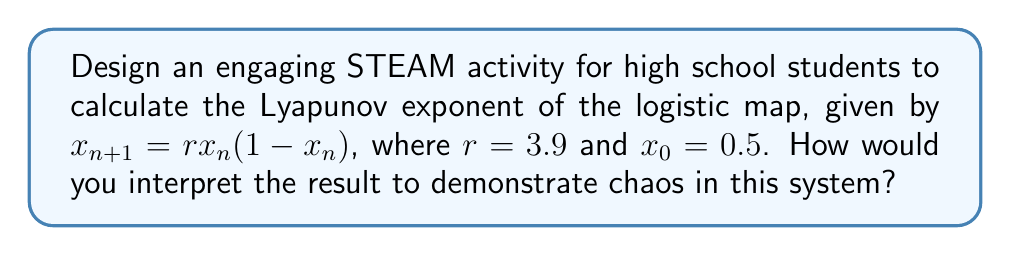Solve this math problem. To calculate the Lyapunov exponent for the logistic map and create an engaging STEAM activity:

1. Introduce the concept:
   The Lyapunov exponent quantifies the rate of separation of infinitesimally close trajectories in a dynamical system. A positive exponent indicates chaos.

2. Set up the calculation:
   For the logistic map, $f(x) = rx(1-x)$, the Lyapunov exponent λ is given by:

   $$λ = \lim_{N→∞} \frac{1}{N} \sum_{n=0}^{N-1} \ln|f'(x_n)|$$

   where $f'(x) = r(1-2x)$ is the derivative of $f(x)$.

3. Implement the calculation:
   a) Use a spreadsheet or programming language to iterate the map:
      $x_{n+1} = 3.9x_n(1-x_n)$, starting with $x_0 = 0.5$
   b) Calculate $f'(x_n) = 3.9(1-2x_n)$ for each iteration
   c) Compute $\ln|f'(x_n)|$ for each step
   d) Sum the results and divide by the number of iterations

4. Perform the calculation for increasing N (e.g., 100, 1000, 10000) to observe convergence.

5. Interpret the result:
   A positive Lyapunov exponent indicates exponential divergence of nearby trajectories, a hallmark of chaos.

6. Visualize chaos:
   Plot the trajectory of $x_n$ vs. n to observe the irregular, non-repeating pattern.

7. Extend the activity:
   Encourage students to experiment with different r values and initial conditions to explore the transition to chaos.
Answer: λ ≈ 0.494 (positive, indicating chaos) 